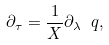Convert formula to latex. <formula><loc_0><loc_0><loc_500><loc_500>\partial _ { \tau } = \frac { 1 } { X } \partial _ { \lambda } \ q ,</formula> 